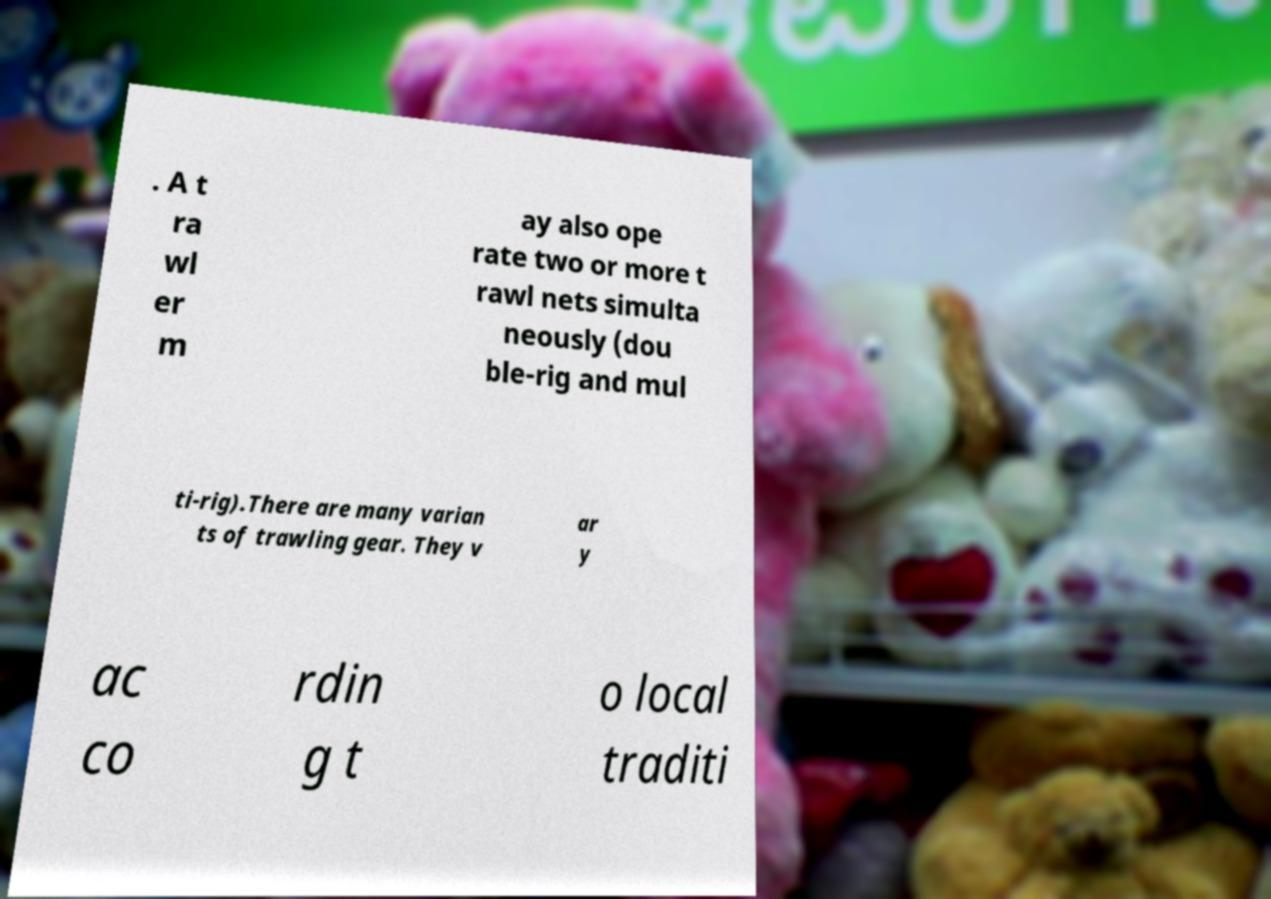Could you extract and type out the text from this image? . A t ra wl er m ay also ope rate two or more t rawl nets simulta neously (dou ble-rig and mul ti-rig).There are many varian ts of trawling gear. They v ar y ac co rdin g t o local traditi 